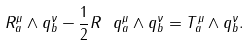<formula> <loc_0><loc_0><loc_500><loc_500>R _ { a } ^ { \mu } \wedge q _ { b } ^ { \nu } - \frac { 1 } { 2 } R \ q _ { a } ^ { \mu } \wedge q _ { b } ^ { \nu } = T _ { a } ^ { \mu } \wedge q _ { b } ^ { \nu } .</formula> 